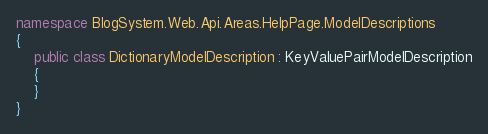<code> <loc_0><loc_0><loc_500><loc_500><_C#_>namespace BlogSystem.Web.Api.Areas.HelpPage.ModelDescriptions
{
    public class DictionaryModelDescription : KeyValuePairModelDescription
    {
    }
}</code> 